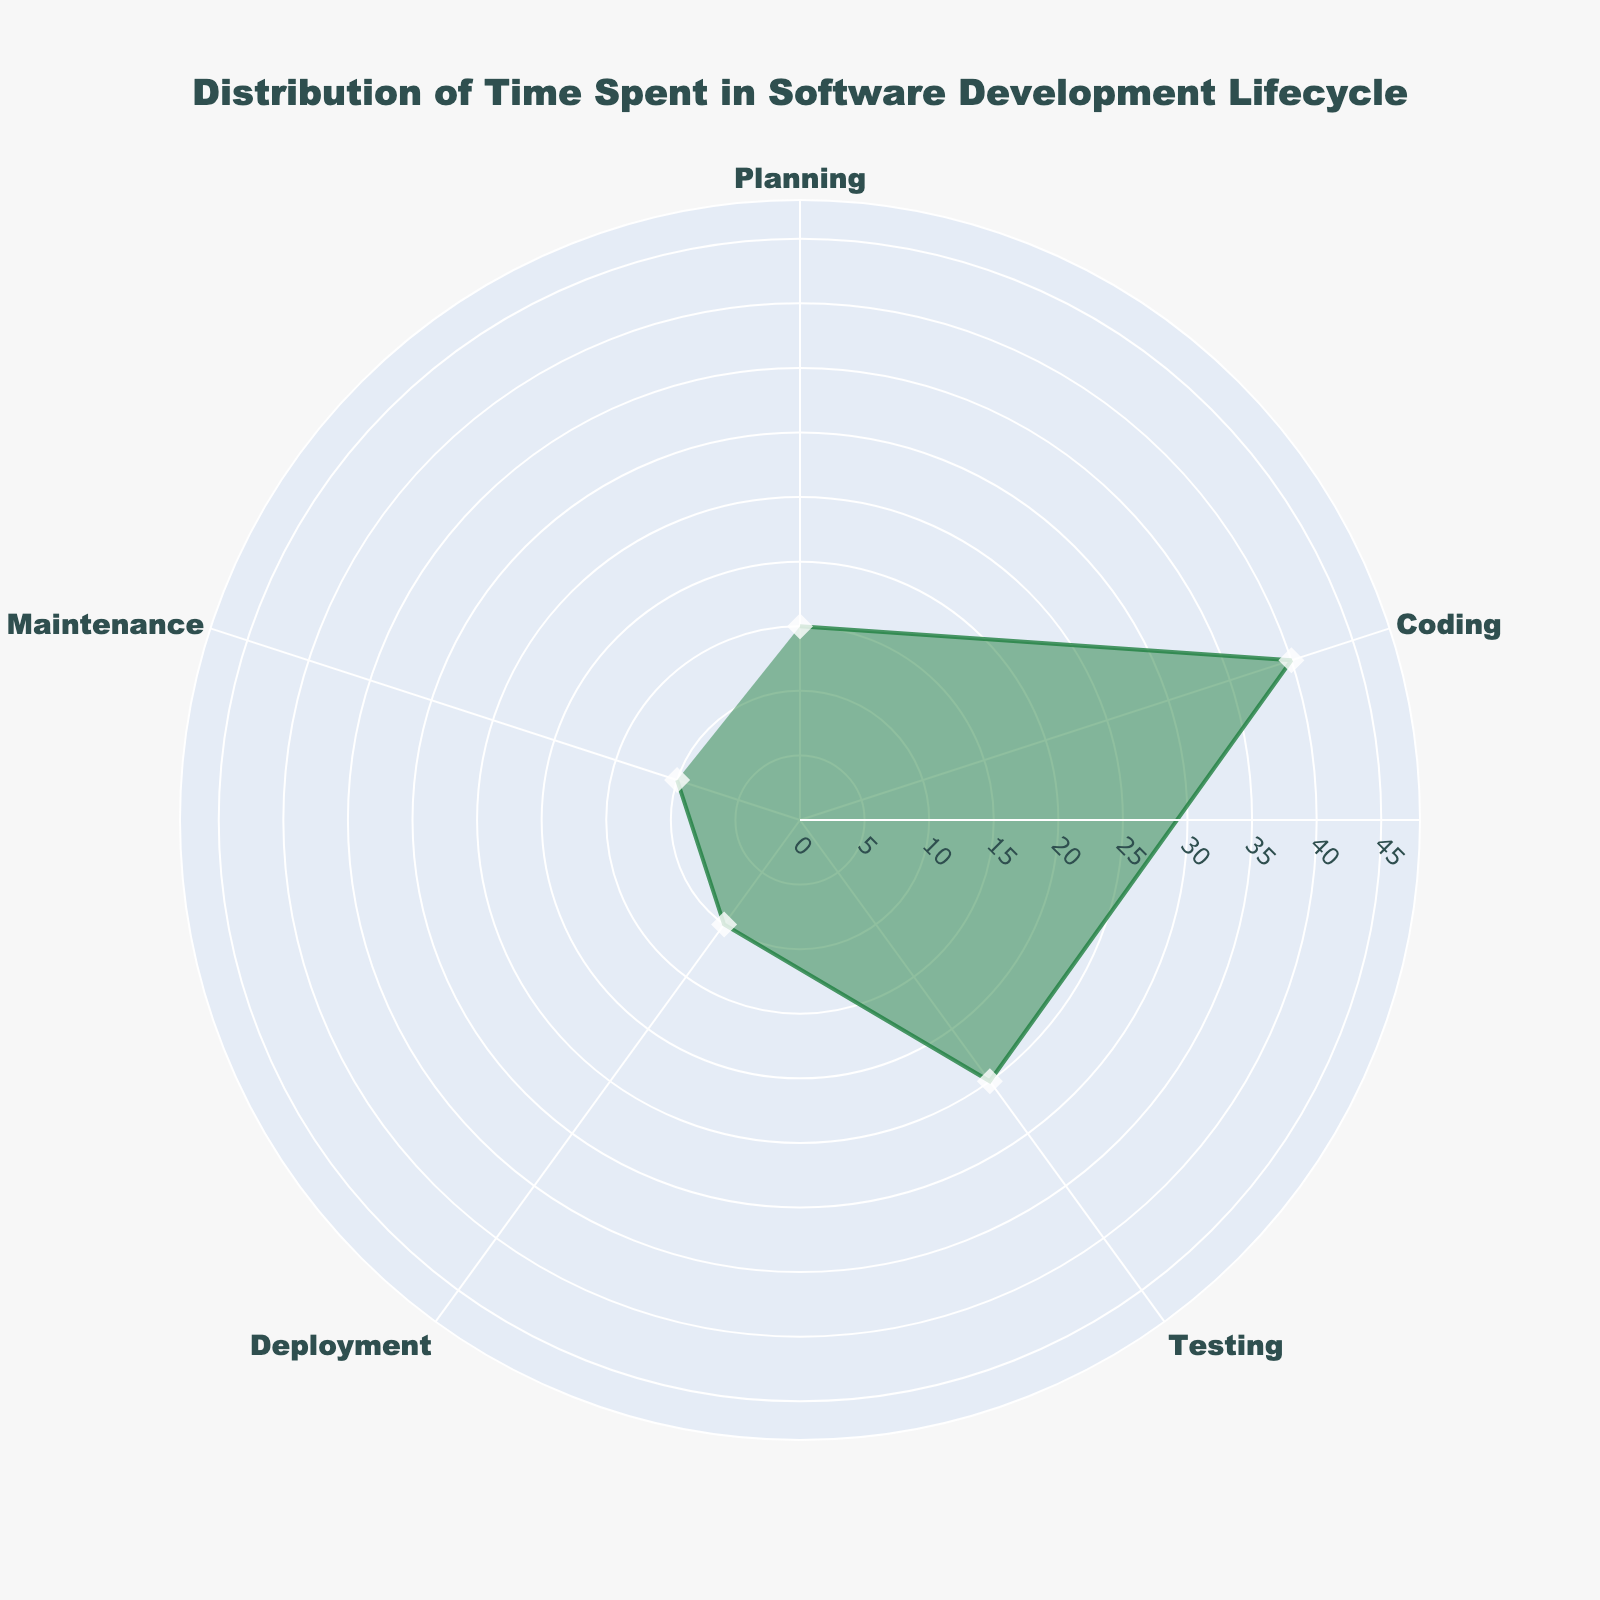Q1: What is the title of the figure? The title of the figure is clearly displayed at the top.
Answer: Distribution of Time Spent in Software Development Lifecycle Q2: Which phase has the highest percentage of time spent? The largest segment in the polar area chart and the corresponding label indicate the highest percentage.
Answer: Coding Q3: What is the combined percentage of time spent on Deployment and Maintenance? Sum the percentages of Deployment (10%) and Maintenance (10%). 10 + 10 = 20
Answer: 20% Q4: How does the percentage of time spent on Testing compare to that on Planning? Check the percentage values for both phases. Testing is 25% while Planning is 15%, and 25% is greater than 15%.
Answer: Testing is higher than Planning Q5: Which phases have exactly 10% of time spent? Identify phases where the percentage values are 10%.
Answer: Deployment and Maintenance Q6: By how much does the time spent on Coding exceed the time spent on Deployment? Subtract the percentage of Deployment (10%) from the percentage of Coding (40%). 40 - 10 = 30
Answer: 30% Q7: What is the visual representation of the data points in terms of markers? The markers are represented by symbols within the chart. Each point is marked by a diamond symbol.
Answer: Diamond symbols Q8: What is the percentage difference between Testing and Maintenance? Subtract the percentage of Maintenance (10%) from the percentage of Testing (25%). 25 - 10 = 15
Answer: 15% Q9: Which phase has the second highest percentage of time spent? Check the percentages of all phases and identify the second highest value after Coding (40%). Testing is 25%, which is the second highest.
Answer: Testing Q10: How many phases have their time spent percentage greater than 20%? Count the number of phases where the percentage is more than 20%. Only Coding (40%) and Testing (25%) meet this criterion.
Answer: Two 